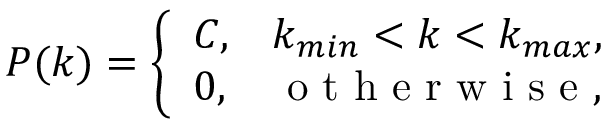Convert formula to latex. <formula><loc_0><loc_0><loc_500><loc_500>P ( k ) = \left \{ \begin{array} { l l } { C , } & { k _ { \min } < k < k _ { \max } , } \\ { 0 , } & { o t h e r w i s e , } \end{array}</formula> 